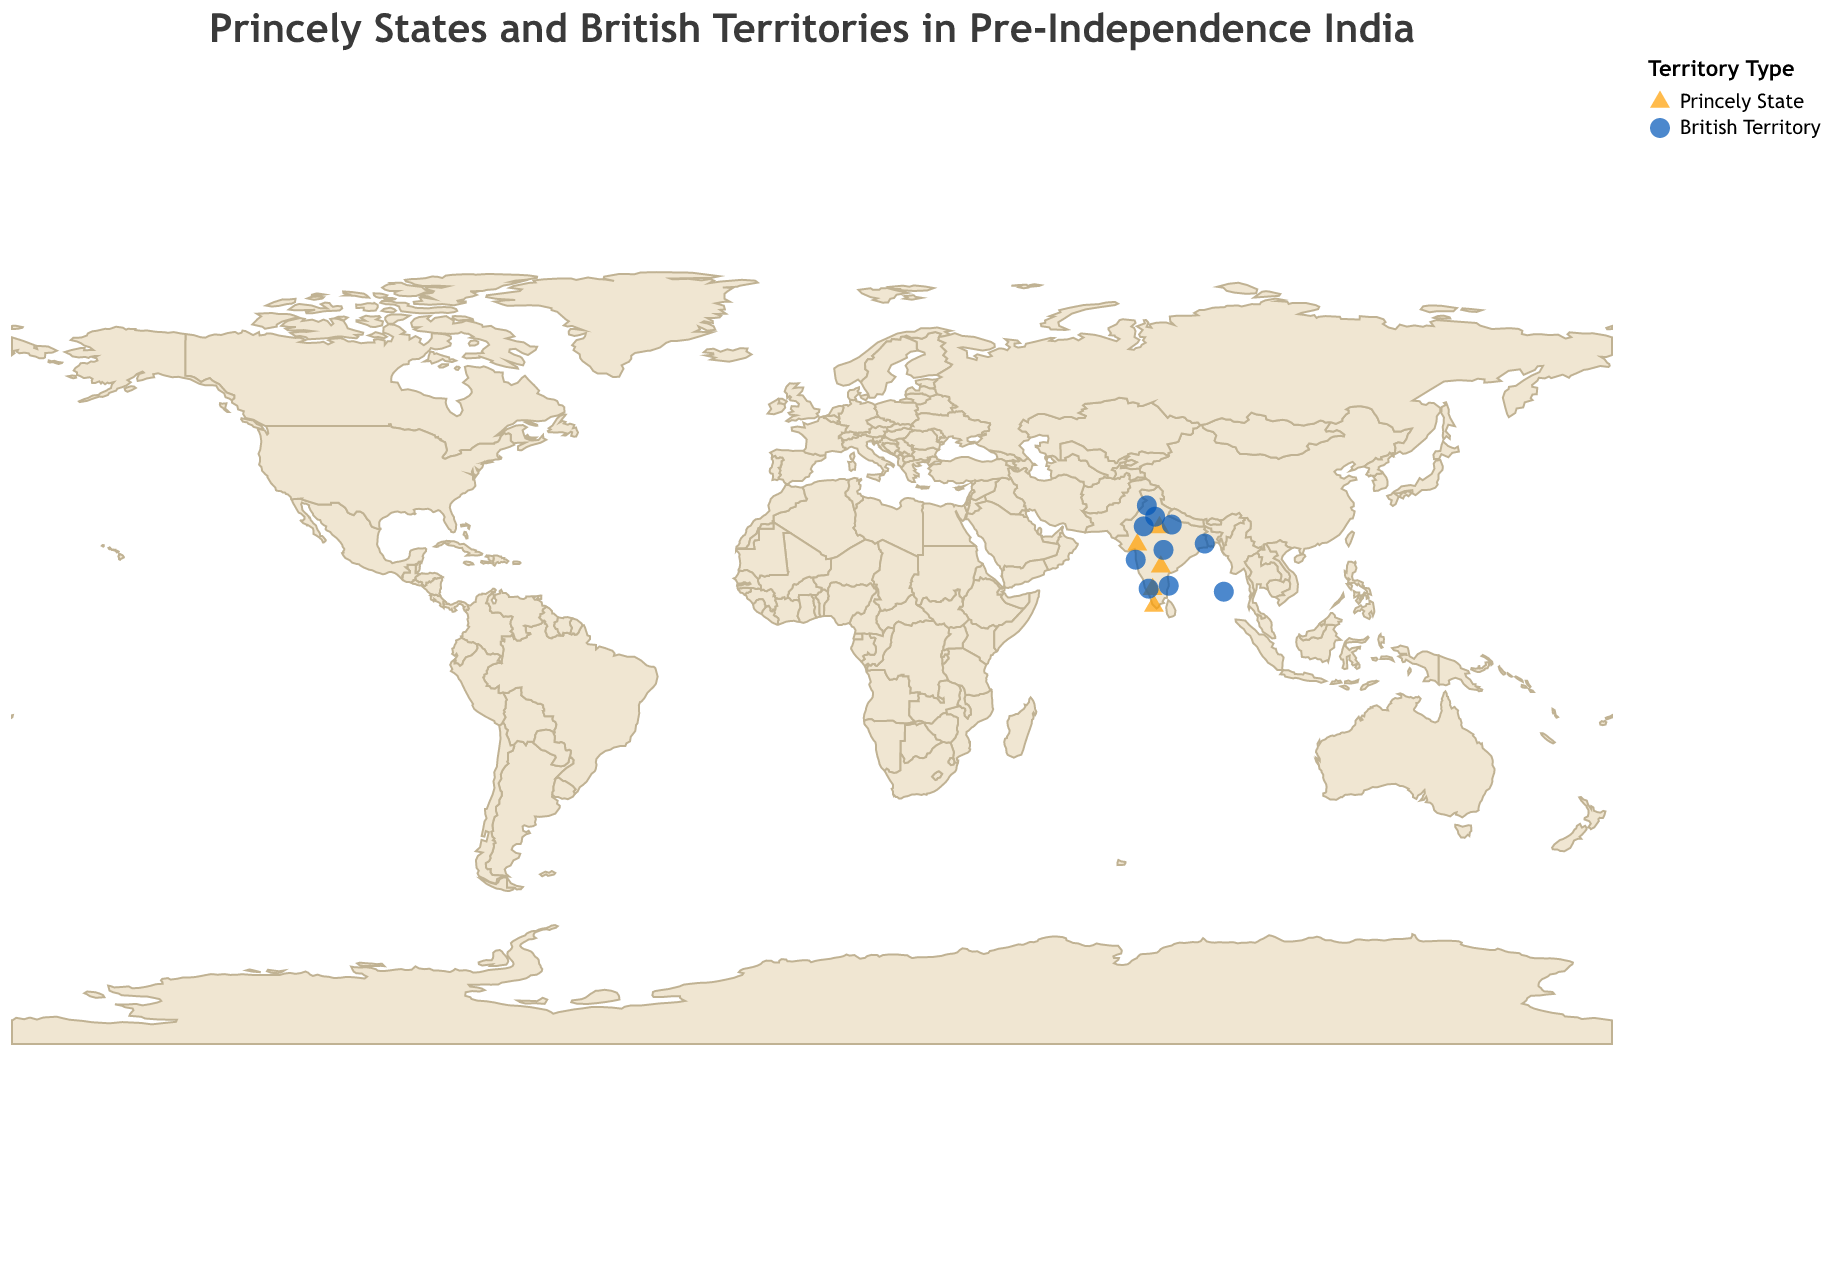What is the title of the figure? The title of the figure is displayed at the top of the plot.
Answer: Princely States and British Territories in Pre-Independence India How many states are marked as Princely States? To count the number of states marked as Princely States, look for the points that are colored according to the color legend provided for "Princely State" and count them.
Answer: 5 Which state is located farthest south? To determine which state is located the farthest south, compare the latitudes of all the states and identify the one with the smallest latitude value. Travancore has the lowest latitude (8.5241).
Answer: Travancore What shapes represent Princely States and British Territories? The shapes representing different types of territories are indicated in the legend. Princely States are represented by triangles, while British Territories are represented by circles.
Answer: Triangles for Princely States and circles for British Territories Which state has the highest latitude value? To find the state with the highest latitude, sort all states by their latitude values in descending order and pick the top one. Punjab has the highest latitude (31.1471).
Answer: Punjab How many British Territories are plotted on the map? To find the number of British Territories, simply count the number of points labeled as British Territories, indicated by circles in the plot.
Answer: 10 Are there more Princely States or British Territories? Compare the number of data points represented as Princely States and British Territories. Since there are 5 Princely States and 10 British Territories, there are more British Territories.
Answer: British Territories Which British Territory is closest to Hyderabad? To find the closest British Territory to Hyderabad, calculate the distance from Hyderabad's coordinates (Latitude: 17.385, Longitude: 78.4867) to each British Territory's coordinates and find the smallest distance. The closest one is Madras Presidency.
Answer: Madras Presidency Which Princely State is located at the highest longitude? Sort the Princely States by their longitude values in descending order and identify the one with the highest longitude value. Hyderabad is at the highest longitude (78.4867).
Answer: Hyderabad What color represents British Territories in the plot? The color representing British Territories is indicated in the legend. According to the legend, British Territories are represented by the color blue.
Answer: Blue 